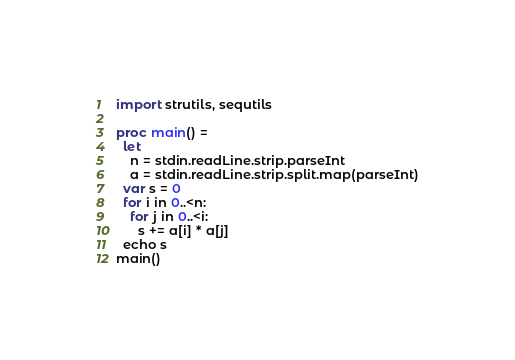<code> <loc_0><loc_0><loc_500><loc_500><_Nim_>import strutils, sequtils

proc main() =
  let
    n = stdin.readLine.strip.parseInt
    a = stdin.readLine.strip.split.map(parseInt)
  var s = 0
  for i in 0..<n:
    for j in 0..<i:
      s += a[i] * a[j]
  echo s
main()
</code> 